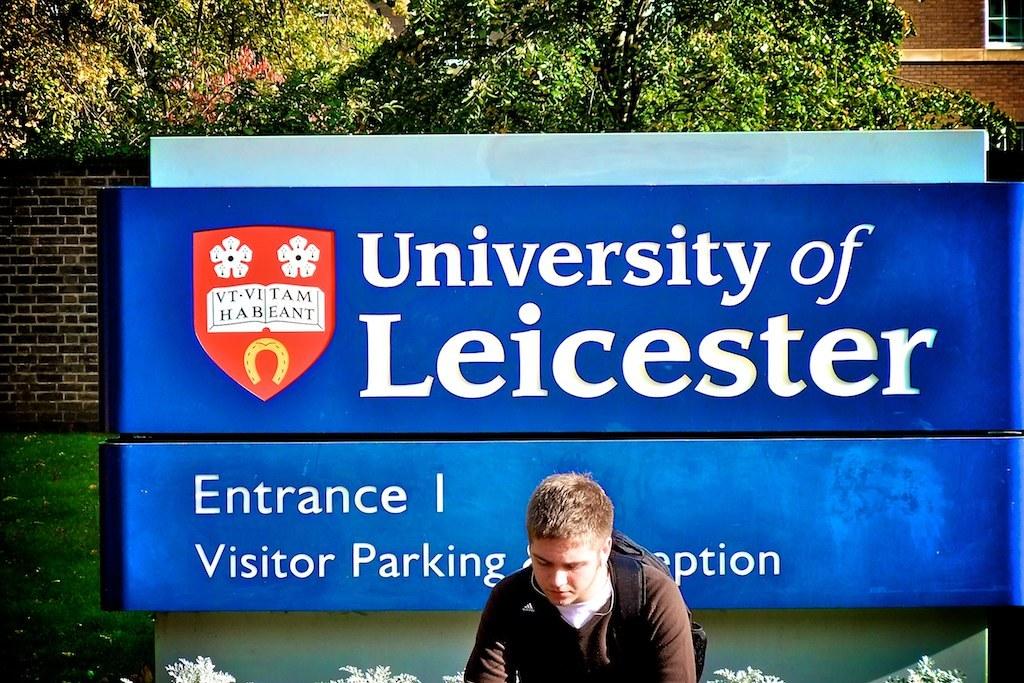What university is this?
Your answer should be compact. Leicester. What does it say under the word entrance?
Ensure brevity in your answer.  Visitor parking. 